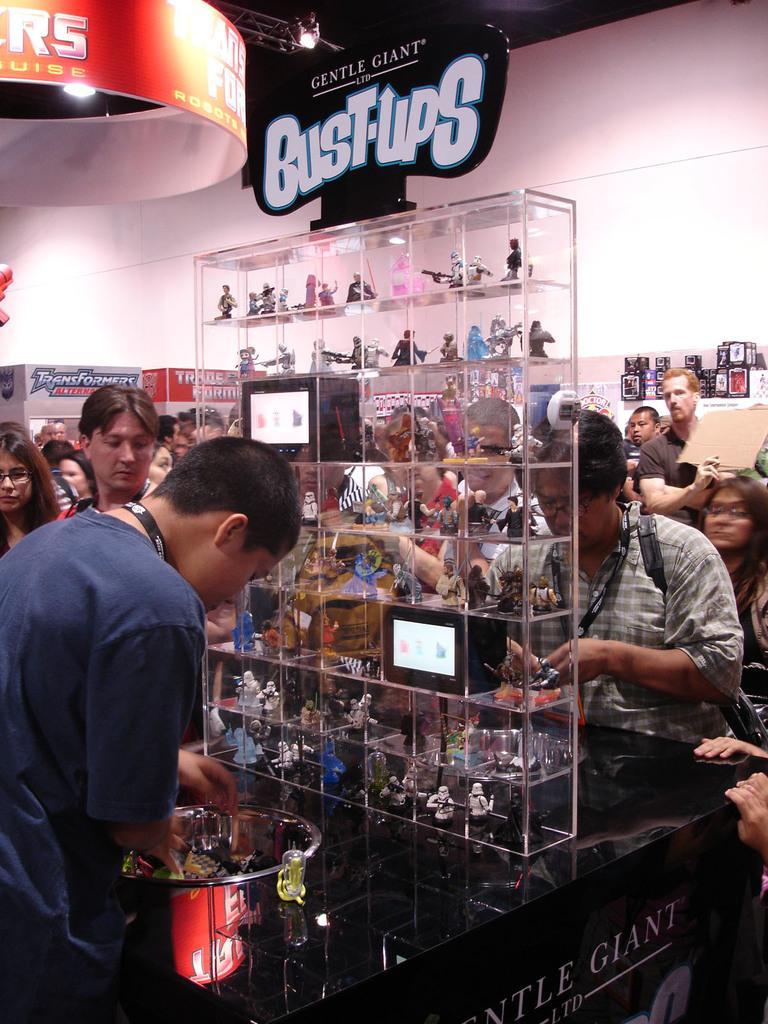In one or two sentences, can you explain what this image depicts? In this picture there is a man who is wearing t-shirt and trouser. He is standing near to this table. On the table I can see a bowl and other objects. On this plastic boxes racks I can see the toys. in the back I can see many people who are standing near to the wall.. At the top I can see the posts and boards. 